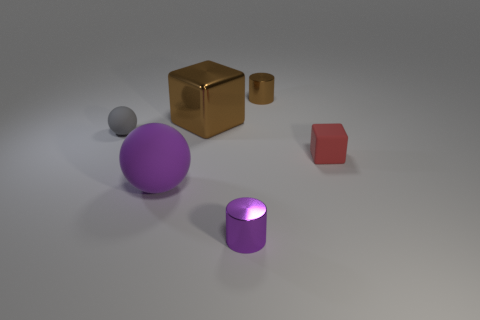The big brown object in front of the brown metal thing that is to the right of the small purple cylinder is what shape?
Provide a succinct answer. Cube. Is there any other thing that is the same size as the purple ball?
Offer a very short reply. Yes. Are there more tiny brown metal things than small metallic things?
Keep it short and to the point. No. There is a cylinder behind the small gray rubber ball on the left side of the small object in front of the purple matte thing; what is its size?
Keep it short and to the point. Small. Do the gray matte sphere and the brown object in front of the tiny brown cylinder have the same size?
Provide a succinct answer. No. Is the number of brown things that are to the left of the big purple rubber ball less than the number of big blue shiny objects?
Ensure brevity in your answer.  No. How many small shiny cylinders have the same color as the large cube?
Your answer should be very brief. 1. Is the number of tiny brown things less than the number of big brown metallic cylinders?
Your answer should be compact. No. Do the tiny purple thing and the tiny red cube have the same material?
Provide a short and direct response. No. What number of other things are there of the same size as the brown metallic cylinder?
Your answer should be compact. 3. 